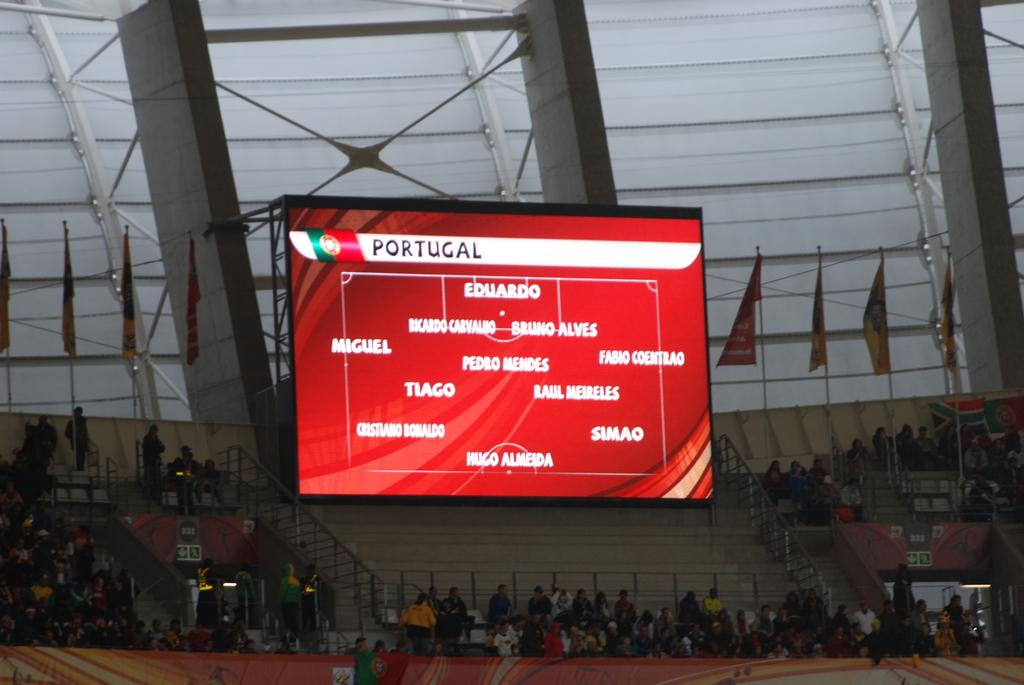What is the top name on the screen?
Keep it short and to the point. Portugal. 